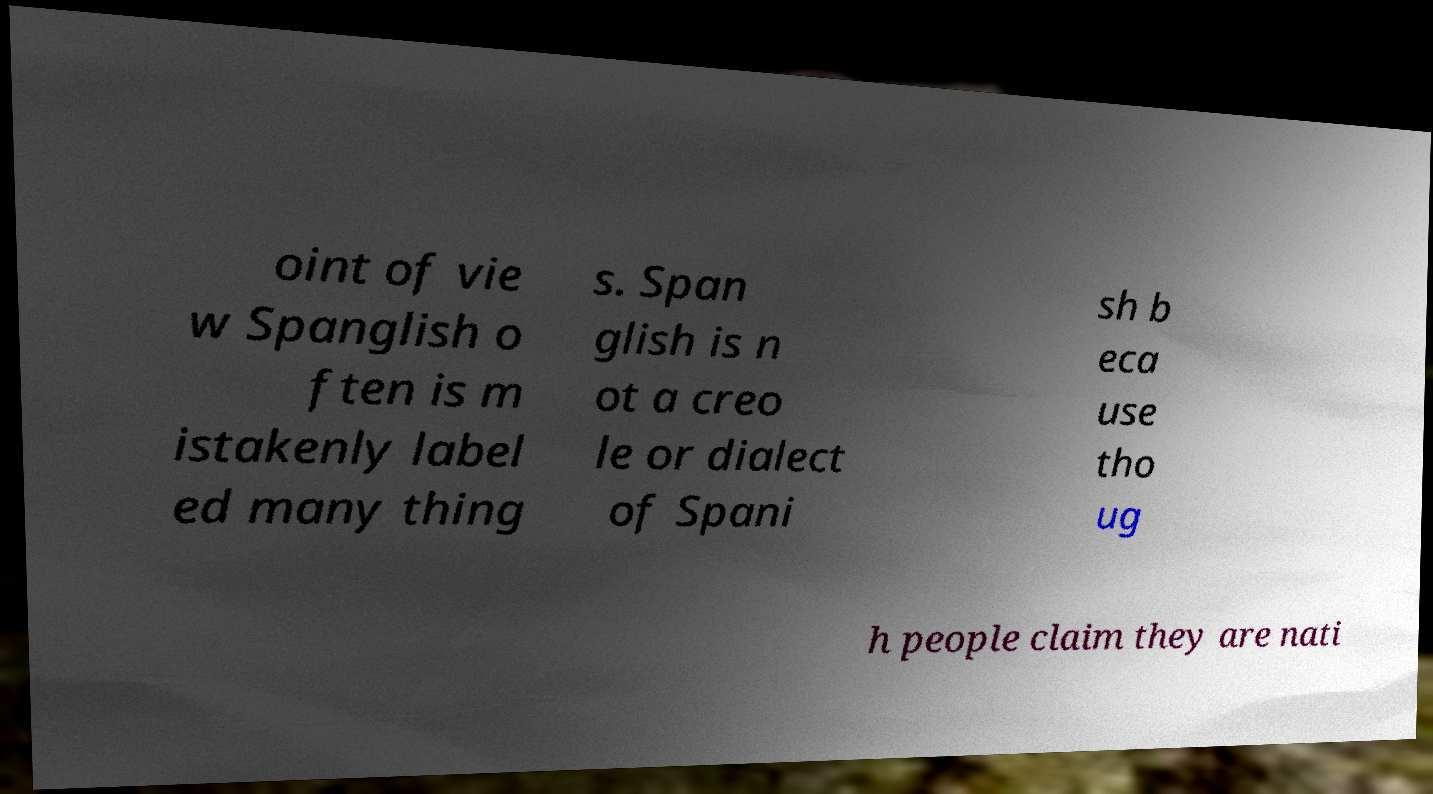Could you assist in decoding the text presented in this image and type it out clearly? oint of vie w Spanglish o ften is m istakenly label ed many thing s. Span glish is n ot a creo le or dialect of Spani sh b eca use tho ug h people claim they are nati 